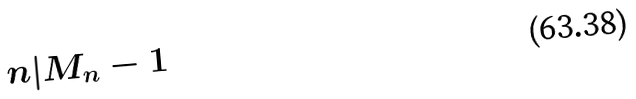Convert formula to latex. <formula><loc_0><loc_0><loc_500><loc_500>n | M _ { n } - 1</formula> 